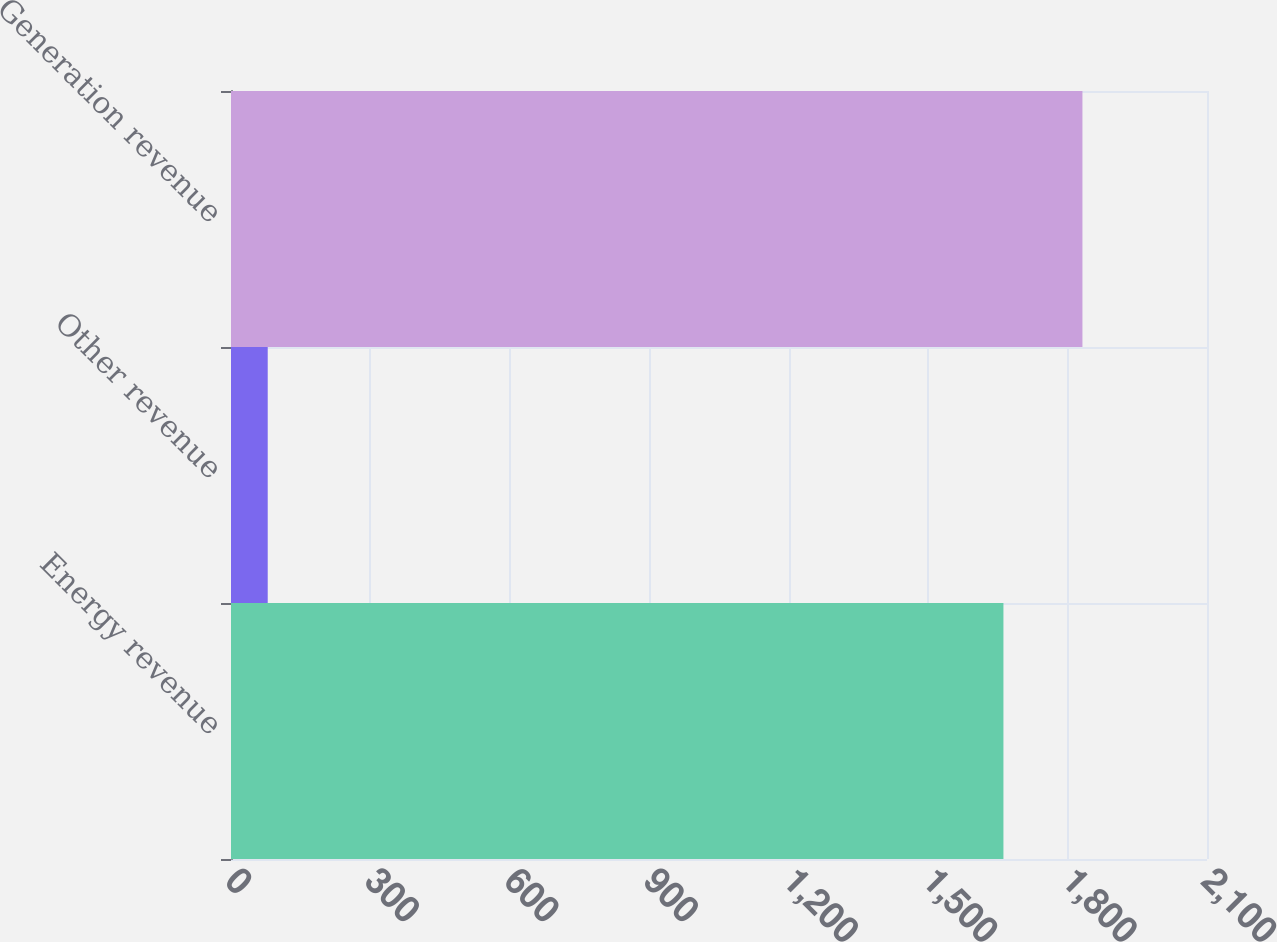Convert chart. <chart><loc_0><loc_0><loc_500><loc_500><bar_chart><fcel>Energy revenue<fcel>Other revenue<fcel>Generation revenue<nl><fcel>1662<fcel>79<fcel>1832<nl></chart> 